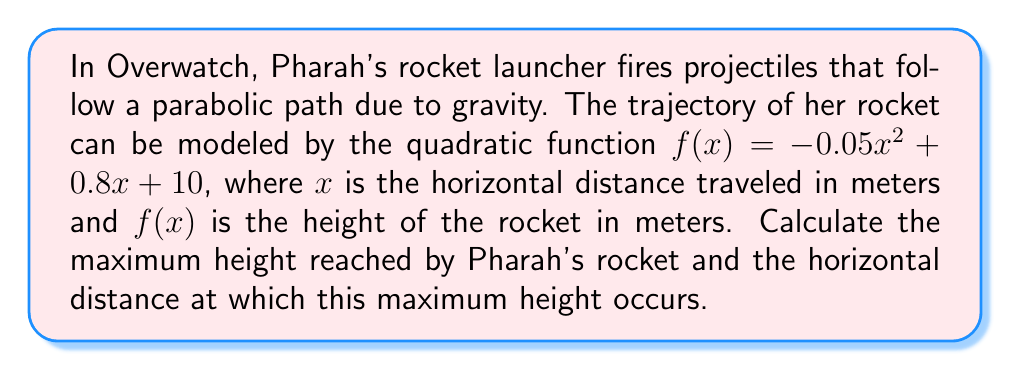Can you solve this math problem? To solve this problem, we need to follow these steps:

1) The quadratic function is in the form $f(x) = ax^2 + bx + c$, where:
   $a = -0.05$
   $b = 0.8$
   $c = 10$

2) For a quadratic function, the x-coordinate of the vertex represents the horizontal distance at which the maximum height occurs. We can find this using the formula:

   $x = -\frac{b}{2a}$

3) Substituting our values:

   $x = -\frac{0.8}{2(-0.05)} = -\frac{0.8}{-0.1} = 8$ meters

4) To find the maximum height, we need to calculate $f(8)$:

   $f(8) = -0.05(8)^2 + 0.8(8) + 10$
   $    = -0.05(64) + 6.4 + 10$
   $    = -3.2 + 6.4 + 10$
   $    = 13.2$ meters

Therefore, the maximum height is reached at a horizontal distance of 8 meters, and the maximum height is 13.2 meters.
Answer: Maximum height: 13.2 meters
Horizontal distance at maximum height: 8 meters 